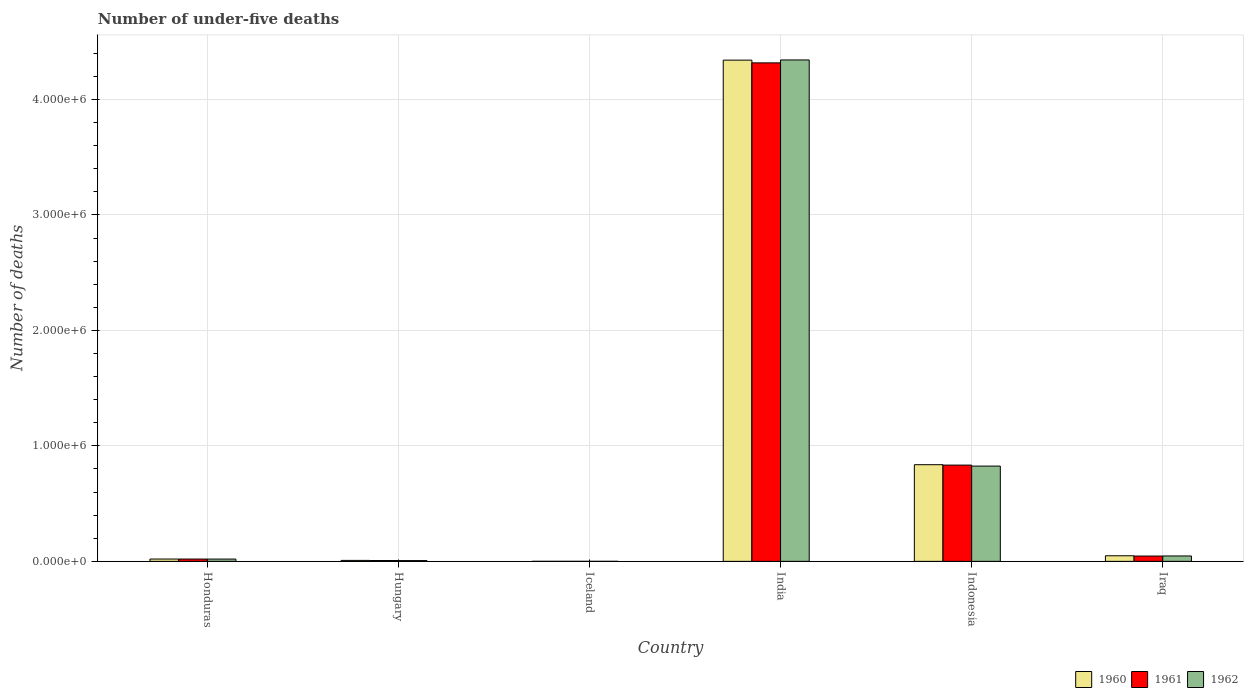How many groups of bars are there?
Offer a terse response. 6. Are the number of bars on each tick of the X-axis equal?
Ensure brevity in your answer.  Yes. What is the label of the 6th group of bars from the left?
Provide a succinct answer. Iraq. What is the number of under-five deaths in 1961 in Iraq?
Keep it short and to the point. 4.60e+04. Across all countries, what is the maximum number of under-five deaths in 1962?
Your response must be concise. 4.34e+06. Across all countries, what is the minimum number of under-five deaths in 1960?
Give a very brief answer. 105. In which country was the number of under-five deaths in 1960 maximum?
Provide a short and direct response. India. In which country was the number of under-five deaths in 1962 minimum?
Provide a succinct answer. Iceland. What is the total number of under-five deaths in 1962 in the graph?
Provide a succinct answer. 5.24e+06. What is the difference between the number of under-five deaths in 1961 in Iceland and that in Iraq?
Your answer should be very brief. -4.59e+04. What is the difference between the number of under-five deaths in 1962 in Iraq and the number of under-five deaths in 1960 in Indonesia?
Provide a succinct answer. -7.90e+05. What is the average number of under-five deaths in 1960 per country?
Offer a terse response. 8.76e+05. What is the difference between the number of under-five deaths of/in 1960 and number of under-five deaths of/in 1962 in Iraq?
Offer a very short reply. 1598. What is the ratio of the number of under-five deaths in 1962 in Hungary to that in Indonesia?
Make the answer very short. 0.01. Is the number of under-five deaths in 1962 in Iceland less than that in Indonesia?
Keep it short and to the point. Yes. Is the difference between the number of under-five deaths in 1960 in Indonesia and Iraq greater than the difference between the number of under-five deaths in 1962 in Indonesia and Iraq?
Your answer should be very brief. Yes. What is the difference between the highest and the second highest number of under-five deaths in 1961?
Provide a short and direct response. 4.27e+06. What is the difference between the highest and the lowest number of under-five deaths in 1960?
Your answer should be compact. 4.34e+06. Is the sum of the number of under-five deaths in 1960 in Honduras and Iceland greater than the maximum number of under-five deaths in 1962 across all countries?
Your response must be concise. No. How many bars are there?
Provide a succinct answer. 18. Are all the bars in the graph horizontal?
Ensure brevity in your answer.  No. How many countries are there in the graph?
Ensure brevity in your answer.  6. Are the values on the major ticks of Y-axis written in scientific E-notation?
Provide a succinct answer. Yes. Does the graph contain any zero values?
Provide a succinct answer. No. Does the graph contain grids?
Offer a very short reply. Yes. Where does the legend appear in the graph?
Provide a succinct answer. Bottom right. How are the legend labels stacked?
Keep it short and to the point. Horizontal. What is the title of the graph?
Ensure brevity in your answer.  Number of under-five deaths. Does "2013" appear as one of the legend labels in the graph?
Your answer should be compact. No. What is the label or title of the X-axis?
Offer a terse response. Country. What is the label or title of the Y-axis?
Your answer should be very brief. Number of deaths. What is the Number of deaths in 1960 in Honduras?
Make the answer very short. 2.01e+04. What is the Number of deaths in 1961 in Honduras?
Give a very brief answer. 1.99e+04. What is the Number of deaths of 1962 in Honduras?
Offer a terse response. 1.98e+04. What is the Number of deaths in 1960 in Hungary?
Ensure brevity in your answer.  8312. What is the Number of deaths of 1961 in Hungary?
Provide a succinct answer. 7255. What is the Number of deaths in 1962 in Hungary?
Give a very brief answer. 6645. What is the Number of deaths of 1960 in Iceland?
Offer a very short reply. 105. What is the Number of deaths in 1961 in Iceland?
Keep it short and to the point. 104. What is the Number of deaths in 1962 in Iceland?
Provide a succinct answer. 102. What is the Number of deaths of 1960 in India?
Provide a short and direct response. 4.34e+06. What is the Number of deaths in 1961 in India?
Offer a very short reply. 4.32e+06. What is the Number of deaths of 1962 in India?
Ensure brevity in your answer.  4.34e+06. What is the Number of deaths in 1960 in Indonesia?
Offer a very short reply. 8.37e+05. What is the Number of deaths in 1961 in Indonesia?
Offer a terse response. 8.34e+05. What is the Number of deaths of 1962 in Indonesia?
Make the answer very short. 8.25e+05. What is the Number of deaths in 1960 in Iraq?
Provide a succinct answer. 4.84e+04. What is the Number of deaths of 1961 in Iraq?
Your answer should be compact. 4.60e+04. What is the Number of deaths of 1962 in Iraq?
Offer a terse response. 4.68e+04. Across all countries, what is the maximum Number of deaths of 1960?
Ensure brevity in your answer.  4.34e+06. Across all countries, what is the maximum Number of deaths in 1961?
Make the answer very short. 4.32e+06. Across all countries, what is the maximum Number of deaths of 1962?
Your answer should be compact. 4.34e+06. Across all countries, what is the minimum Number of deaths of 1960?
Give a very brief answer. 105. Across all countries, what is the minimum Number of deaths of 1961?
Make the answer very short. 104. Across all countries, what is the minimum Number of deaths of 1962?
Offer a very short reply. 102. What is the total Number of deaths in 1960 in the graph?
Your response must be concise. 5.25e+06. What is the total Number of deaths of 1961 in the graph?
Your answer should be compact. 5.22e+06. What is the total Number of deaths of 1962 in the graph?
Offer a very short reply. 5.24e+06. What is the difference between the Number of deaths of 1960 in Honduras and that in Hungary?
Your response must be concise. 1.18e+04. What is the difference between the Number of deaths of 1961 in Honduras and that in Hungary?
Keep it short and to the point. 1.27e+04. What is the difference between the Number of deaths of 1962 in Honduras and that in Hungary?
Keep it short and to the point. 1.32e+04. What is the difference between the Number of deaths in 1960 in Honduras and that in Iceland?
Make the answer very short. 2.00e+04. What is the difference between the Number of deaths of 1961 in Honduras and that in Iceland?
Give a very brief answer. 1.98e+04. What is the difference between the Number of deaths in 1962 in Honduras and that in Iceland?
Offer a terse response. 1.97e+04. What is the difference between the Number of deaths in 1960 in Honduras and that in India?
Your answer should be compact. -4.32e+06. What is the difference between the Number of deaths of 1961 in Honduras and that in India?
Keep it short and to the point. -4.30e+06. What is the difference between the Number of deaths in 1962 in Honduras and that in India?
Offer a very short reply. -4.32e+06. What is the difference between the Number of deaths in 1960 in Honduras and that in Indonesia?
Offer a terse response. -8.17e+05. What is the difference between the Number of deaths of 1961 in Honduras and that in Indonesia?
Offer a very short reply. -8.14e+05. What is the difference between the Number of deaths in 1962 in Honduras and that in Indonesia?
Ensure brevity in your answer.  -8.05e+05. What is the difference between the Number of deaths in 1960 in Honduras and that in Iraq?
Your answer should be compact. -2.83e+04. What is the difference between the Number of deaths of 1961 in Honduras and that in Iraq?
Give a very brief answer. -2.61e+04. What is the difference between the Number of deaths of 1962 in Honduras and that in Iraq?
Your answer should be very brief. -2.70e+04. What is the difference between the Number of deaths of 1960 in Hungary and that in Iceland?
Offer a terse response. 8207. What is the difference between the Number of deaths in 1961 in Hungary and that in Iceland?
Offer a very short reply. 7151. What is the difference between the Number of deaths in 1962 in Hungary and that in Iceland?
Keep it short and to the point. 6543. What is the difference between the Number of deaths in 1960 in Hungary and that in India?
Provide a short and direct response. -4.33e+06. What is the difference between the Number of deaths of 1961 in Hungary and that in India?
Keep it short and to the point. -4.31e+06. What is the difference between the Number of deaths of 1962 in Hungary and that in India?
Keep it short and to the point. -4.34e+06. What is the difference between the Number of deaths of 1960 in Hungary and that in Indonesia?
Your answer should be very brief. -8.29e+05. What is the difference between the Number of deaths of 1961 in Hungary and that in Indonesia?
Offer a terse response. -8.26e+05. What is the difference between the Number of deaths of 1962 in Hungary and that in Indonesia?
Provide a short and direct response. -8.18e+05. What is the difference between the Number of deaths in 1960 in Hungary and that in Iraq?
Your response must be concise. -4.01e+04. What is the difference between the Number of deaths of 1961 in Hungary and that in Iraq?
Make the answer very short. -3.88e+04. What is the difference between the Number of deaths of 1962 in Hungary and that in Iraq?
Provide a short and direct response. -4.02e+04. What is the difference between the Number of deaths in 1960 in Iceland and that in India?
Provide a succinct answer. -4.34e+06. What is the difference between the Number of deaths of 1961 in Iceland and that in India?
Your answer should be very brief. -4.32e+06. What is the difference between the Number of deaths of 1962 in Iceland and that in India?
Give a very brief answer. -4.34e+06. What is the difference between the Number of deaths of 1960 in Iceland and that in Indonesia?
Offer a very short reply. -8.37e+05. What is the difference between the Number of deaths in 1961 in Iceland and that in Indonesia?
Give a very brief answer. -8.33e+05. What is the difference between the Number of deaths in 1962 in Iceland and that in Indonesia?
Ensure brevity in your answer.  -8.25e+05. What is the difference between the Number of deaths in 1960 in Iceland and that in Iraq?
Offer a very short reply. -4.83e+04. What is the difference between the Number of deaths in 1961 in Iceland and that in Iraq?
Keep it short and to the point. -4.59e+04. What is the difference between the Number of deaths of 1962 in Iceland and that in Iraq?
Your response must be concise. -4.67e+04. What is the difference between the Number of deaths in 1960 in India and that in Indonesia?
Give a very brief answer. 3.50e+06. What is the difference between the Number of deaths of 1961 in India and that in Indonesia?
Make the answer very short. 3.48e+06. What is the difference between the Number of deaths in 1962 in India and that in Indonesia?
Give a very brief answer. 3.52e+06. What is the difference between the Number of deaths of 1960 in India and that in Iraq?
Your answer should be compact. 4.29e+06. What is the difference between the Number of deaths in 1961 in India and that in Iraq?
Ensure brevity in your answer.  4.27e+06. What is the difference between the Number of deaths in 1962 in India and that in Iraq?
Offer a terse response. 4.30e+06. What is the difference between the Number of deaths in 1960 in Indonesia and that in Iraq?
Give a very brief answer. 7.89e+05. What is the difference between the Number of deaths in 1961 in Indonesia and that in Iraq?
Give a very brief answer. 7.88e+05. What is the difference between the Number of deaths in 1962 in Indonesia and that in Iraq?
Keep it short and to the point. 7.78e+05. What is the difference between the Number of deaths of 1960 in Honduras and the Number of deaths of 1961 in Hungary?
Give a very brief answer. 1.28e+04. What is the difference between the Number of deaths of 1960 in Honduras and the Number of deaths of 1962 in Hungary?
Provide a succinct answer. 1.35e+04. What is the difference between the Number of deaths of 1961 in Honduras and the Number of deaths of 1962 in Hungary?
Provide a succinct answer. 1.33e+04. What is the difference between the Number of deaths in 1960 in Honduras and the Number of deaths in 1961 in Iceland?
Keep it short and to the point. 2.00e+04. What is the difference between the Number of deaths in 1960 in Honduras and the Number of deaths in 1962 in Iceland?
Offer a very short reply. 2.00e+04. What is the difference between the Number of deaths of 1961 in Honduras and the Number of deaths of 1962 in Iceland?
Provide a short and direct response. 1.98e+04. What is the difference between the Number of deaths in 1960 in Honduras and the Number of deaths in 1961 in India?
Give a very brief answer. -4.30e+06. What is the difference between the Number of deaths in 1960 in Honduras and the Number of deaths in 1962 in India?
Your answer should be compact. -4.32e+06. What is the difference between the Number of deaths of 1961 in Honduras and the Number of deaths of 1962 in India?
Your answer should be very brief. -4.32e+06. What is the difference between the Number of deaths of 1960 in Honduras and the Number of deaths of 1961 in Indonesia?
Give a very brief answer. -8.13e+05. What is the difference between the Number of deaths of 1960 in Honduras and the Number of deaths of 1962 in Indonesia?
Your response must be concise. -8.05e+05. What is the difference between the Number of deaths in 1961 in Honduras and the Number of deaths in 1962 in Indonesia?
Give a very brief answer. -8.05e+05. What is the difference between the Number of deaths in 1960 in Honduras and the Number of deaths in 1961 in Iraq?
Give a very brief answer. -2.59e+04. What is the difference between the Number of deaths in 1960 in Honduras and the Number of deaths in 1962 in Iraq?
Provide a short and direct response. -2.67e+04. What is the difference between the Number of deaths of 1961 in Honduras and the Number of deaths of 1962 in Iraq?
Your response must be concise. -2.69e+04. What is the difference between the Number of deaths of 1960 in Hungary and the Number of deaths of 1961 in Iceland?
Give a very brief answer. 8208. What is the difference between the Number of deaths in 1960 in Hungary and the Number of deaths in 1962 in Iceland?
Provide a succinct answer. 8210. What is the difference between the Number of deaths in 1961 in Hungary and the Number of deaths in 1962 in Iceland?
Give a very brief answer. 7153. What is the difference between the Number of deaths in 1960 in Hungary and the Number of deaths in 1961 in India?
Offer a very short reply. -4.31e+06. What is the difference between the Number of deaths of 1960 in Hungary and the Number of deaths of 1962 in India?
Provide a short and direct response. -4.33e+06. What is the difference between the Number of deaths in 1961 in Hungary and the Number of deaths in 1962 in India?
Provide a succinct answer. -4.33e+06. What is the difference between the Number of deaths of 1960 in Hungary and the Number of deaths of 1961 in Indonesia?
Provide a succinct answer. -8.25e+05. What is the difference between the Number of deaths of 1960 in Hungary and the Number of deaths of 1962 in Indonesia?
Your answer should be very brief. -8.17e+05. What is the difference between the Number of deaths of 1961 in Hungary and the Number of deaths of 1962 in Indonesia?
Keep it short and to the point. -8.18e+05. What is the difference between the Number of deaths of 1960 in Hungary and the Number of deaths of 1961 in Iraq?
Offer a very short reply. -3.77e+04. What is the difference between the Number of deaths in 1960 in Hungary and the Number of deaths in 1962 in Iraq?
Make the answer very short. -3.85e+04. What is the difference between the Number of deaths in 1961 in Hungary and the Number of deaths in 1962 in Iraq?
Offer a very short reply. -3.95e+04. What is the difference between the Number of deaths of 1960 in Iceland and the Number of deaths of 1961 in India?
Give a very brief answer. -4.32e+06. What is the difference between the Number of deaths in 1960 in Iceland and the Number of deaths in 1962 in India?
Offer a terse response. -4.34e+06. What is the difference between the Number of deaths in 1961 in Iceland and the Number of deaths in 1962 in India?
Provide a short and direct response. -4.34e+06. What is the difference between the Number of deaths of 1960 in Iceland and the Number of deaths of 1961 in Indonesia?
Provide a short and direct response. -8.33e+05. What is the difference between the Number of deaths in 1960 in Iceland and the Number of deaths in 1962 in Indonesia?
Your answer should be compact. -8.25e+05. What is the difference between the Number of deaths in 1961 in Iceland and the Number of deaths in 1962 in Indonesia?
Keep it short and to the point. -8.25e+05. What is the difference between the Number of deaths in 1960 in Iceland and the Number of deaths in 1961 in Iraq?
Your answer should be very brief. -4.59e+04. What is the difference between the Number of deaths in 1960 in Iceland and the Number of deaths in 1962 in Iraq?
Keep it short and to the point. -4.67e+04. What is the difference between the Number of deaths of 1961 in Iceland and the Number of deaths of 1962 in Iraq?
Offer a very short reply. -4.67e+04. What is the difference between the Number of deaths of 1960 in India and the Number of deaths of 1961 in Indonesia?
Your answer should be very brief. 3.51e+06. What is the difference between the Number of deaths of 1960 in India and the Number of deaths of 1962 in Indonesia?
Provide a succinct answer. 3.52e+06. What is the difference between the Number of deaths of 1961 in India and the Number of deaths of 1962 in Indonesia?
Offer a terse response. 3.49e+06. What is the difference between the Number of deaths of 1960 in India and the Number of deaths of 1961 in Iraq?
Make the answer very short. 4.29e+06. What is the difference between the Number of deaths of 1960 in India and the Number of deaths of 1962 in Iraq?
Provide a short and direct response. 4.29e+06. What is the difference between the Number of deaths in 1961 in India and the Number of deaths in 1962 in Iraq?
Offer a very short reply. 4.27e+06. What is the difference between the Number of deaths of 1960 in Indonesia and the Number of deaths of 1961 in Iraq?
Offer a very short reply. 7.91e+05. What is the difference between the Number of deaths of 1960 in Indonesia and the Number of deaths of 1962 in Iraq?
Give a very brief answer. 7.90e+05. What is the difference between the Number of deaths in 1961 in Indonesia and the Number of deaths in 1962 in Iraq?
Offer a terse response. 7.87e+05. What is the average Number of deaths of 1960 per country?
Make the answer very short. 8.76e+05. What is the average Number of deaths in 1961 per country?
Your response must be concise. 8.71e+05. What is the average Number of deaths in 1962 per country?
Your answer should be very brief. 8.73e+05. What is the difference between the Number of deaths in 1960 and Number of deaths in 1961 in Honduras?
Provide a succinct answer. 178. What is the difference between the Number of deaths of 1960 and Number of deaths of 1962 in Honduras?
Offer a very short reply. 271. What is the difference between the Number of deaths of 1961 and Number of deaths of 1962 in Honduras?
Offer a very short reply. 93. What is the difference between the Number of deaths of 1960 and Number of deaths of 1961 in Hungary?
Offer a very short reply. 1057. What is the difference between the Number of deaths in 1960 and Number of deaths in 1962 in Hungary?
Your answer should be very brief. 1667. What is the difference between the Number of deaths of 1961 and Number of deaths of 1962 in Hungary?
Your answer should be very brief. 610. What is the difference between the Number of deaths of 1961 and Number of deaths of 1962 in Iceland?
Your answer should be compact. 2. What is the difference between the Number of deaths in 1960 and Number of deaths in 1961 in India?
Provide a short and direct response. 2.38e+04. What is the difference between the Number of deaths of 1960 and Number of deaths of 1962 in India?
Your answer should be very brief. -1574. What is the difference between the Number of deaths of 1961 and Number of deaths of 1962 in India?
Offer a very short reply. -2.54e+04. What is the difference between the Number of deaths of 1960 and Number of deaths of 1961 in Indonesia?
Keep it short and to the point. 3494. What is the difference between the Number of deaths of 1960 and Number of deaths of 1962 in Indonesia?
Make the answer very short. 1.20e+04. What is the difference between the Number of deaths of 1961 and Number of deaths of 1962 in Indonesia?
Your response must be concise. 8538. What is the difference between the Number of deaths of 1960 and Number of deaths of 1961 in Iraq?
Keep it short and to the point. 2377. What is the difference between the Number of deaths of 1960 and Number of deaths of 1962 in Iraq?
Provide a succinct answer. 1598. What is the difference between the Number of deaths of 1961 and Number of deaths of 1962 in Iraq?
Keep it short and to the point. -779. What is the ratio of the Number of deaths in 1960 in Honduras to that in Hungary?
Make the answer very short. 2.42. What is the ratio of the Number of deaths of 1961 in Honduras to that in Hungary?
Offer a very short reply. 2.75. What is the ratio of the Number of deaths of 1962 in Honduras to that in Hungary?
Ensure brevity in your answer.  2.98. What is the ratio of the Number of deaths in 1960 in Honduras to that in Iceland?
Provide a succinct answer. 191.46. What is the ratio of the Number of deaths in 1961 in Honduras to that in Iceland?
Keep it short and to the point. 191.59. What is the ratio of the Number of deaths in 1962 in Honduras to that in Iceland?
Provide a short and direct response. 194.43. What is the ratio of the Number of deaths of 1960 in Honduras to that in India?
Give a very brief answer. 0. What is the ratio of the Number of deaths in 1961 in Honduras to that in India?
Your answer should be very brief. 0. What is the ratio of the Number of deaths in 1962 in Honduras to that in India?
Your response must be concise. 0. What is the ratio of the Number of deaths in 1960 in Honduras to that in Indonesia?
Your answer should be compact. 0.02. What is the ratio of the Number of deaths of 1961 in Honduras to that in Indonesia?
Your response must be concise. 0.02. What is the ratio of the Number of deaths of 1962 in Honduras to that in Indonesia?
Keep it short and to the point. 0.02. What is the ratio of the Number of deaths of 1960 in Honduras to that in Iraq?
Give a very brief answer. 0.42. What is the ratio of the Number of deaths in 1961 in Honduras to that in Iraq?
Provide a succinct answer. 0.43. What is the ratio of the Number of deaths in 1962 in Honduras to that in Iraq?
Give a very brief answer. 0.42. What is the ratio of the Number of deaths in 1960 in Hungary to that in Iceland?
Your answer should be very brief. 79.16. What is the ratio of the Number of deaths in 1961 in Hungary to that in Iceland?
Ensure brevity in your answer.  69.76. What is the ratio of the Number of deaths of 1962 in Hungary to that in Iceland?
Keep it short and to the point. 65.15. What is the ratio of the Number of deaths in 1960 in Hungary to that in India?
Ensure brevity in your answer.  0. What is the ratio of the Number of deaths of 1961 in Hungary to that in India?
Your response must be concise. 0. What is the ratio of the Number of deaths in 1962 in Hungary to that in India?
Ensure brevity in your answer.  0. What is the ratio of the Number of deaths of 1960 in Hungary to that in Indonesia?
Your answer should be compact. 0.01. What is the ratio of the Number of deaths in 1961 in Hungary to that in Indonesia?
Give a very brief answer. 0.01. What is the ratio of the Number of deaths of 1962 in Hungary to that in Indonesia?
Your response must be concise. 0.01. What is the ratio of the Number of deaths of 1960 in Hungary to that in Iraq?
Your answer should be compact. 0.17. What is the ratio of the Number of deaths in 1961 in Hungary to that in Iraq?
Ensure brevity in your answer.  0.16. What is the ratio of the Number of deaths of 1962 in Hungary to that in Iraq?
Give a very brief answer. 0.14. What is the ratio of the Number of deaths of 1960 in Iceland to that in India?
Ensure brevity in your answer.  0. What is the ratio of the Number of deaths in 1961 in Iceland to that in India?
Your answer should be very brief. 0. What is the ratio of the Number of deaths in 1962 in Iceland to that in India?
Make the answer very short. 0. What is the ratio of the Number of deaths in 1960 in Iceland to that in Iraq?
Give a very brief answer. 0. What is the ratio of the Number of deaths of 1961 in Iceland to that in Iraq?
Offer a very short reply. 0. What is the ratio of the Number of deaths of 1962 in Iceland to that in Iraq?
Provide a short and direct response. 0. What is the ratio of the Number of deaths of 1960 in India to that in Indonesia?
Your answer should be compact. 5.19. What is the ratio of the Number of deaths in 1961 in India to that in Indonesia?
Make the answer very short. 5.18. What is the ratio of the Number of deaths of 1962 in India to that in Indonesia?
Your answer should be very brief. 5.26. What is the ratio of the Number of deaths in 1960 in India to that in Iraq?
Provide a short and direct response. 89.69. What is the ratio of the Number of deaths of 1961 in India to that in Iraq?
Your response must be concise. 93.8. What is the ratio of the Number of deaths of 1962 in India to that in Iraq?
Make the answer very short. 92.78. What is the ratio of the Number of deaths of 1960 in Indonesia to that in Iraq?
Your answer should be very brief. 17.3. What is the ratio of the Number of deaths of 1961 in Indonesia to that in Iraq?
Make the answer very short. 18.11. What is the ratio of the Number of deaths of 1962 in Indonesia to that in Iraq?
Your response must be concise. 17.63. What is the difference between the highest and the second highest Number of deaths in 1960?
Offer a terse response. 3.50e+06. What is the difference between the highest and the second highest Number of deaths in 1961?
Your answer should be very brief. 3.48e+06. What is the difference between the highest and the second highest Number of deaths of 1962?
Your answer should be very brief. 3.52e+06. What is the difference between the highest and the lowest Number of deaths in 1960?
Provide a succinct answer. 4.34e+06. What is the difference between the highest and the lowest Number of deaths of 1961?
Provide a short and direct response. 4.32e+06. What is the difference between the highest and the lowest Number of deaths of 1962?
Your answer should be very brief. 4.34e+06. 